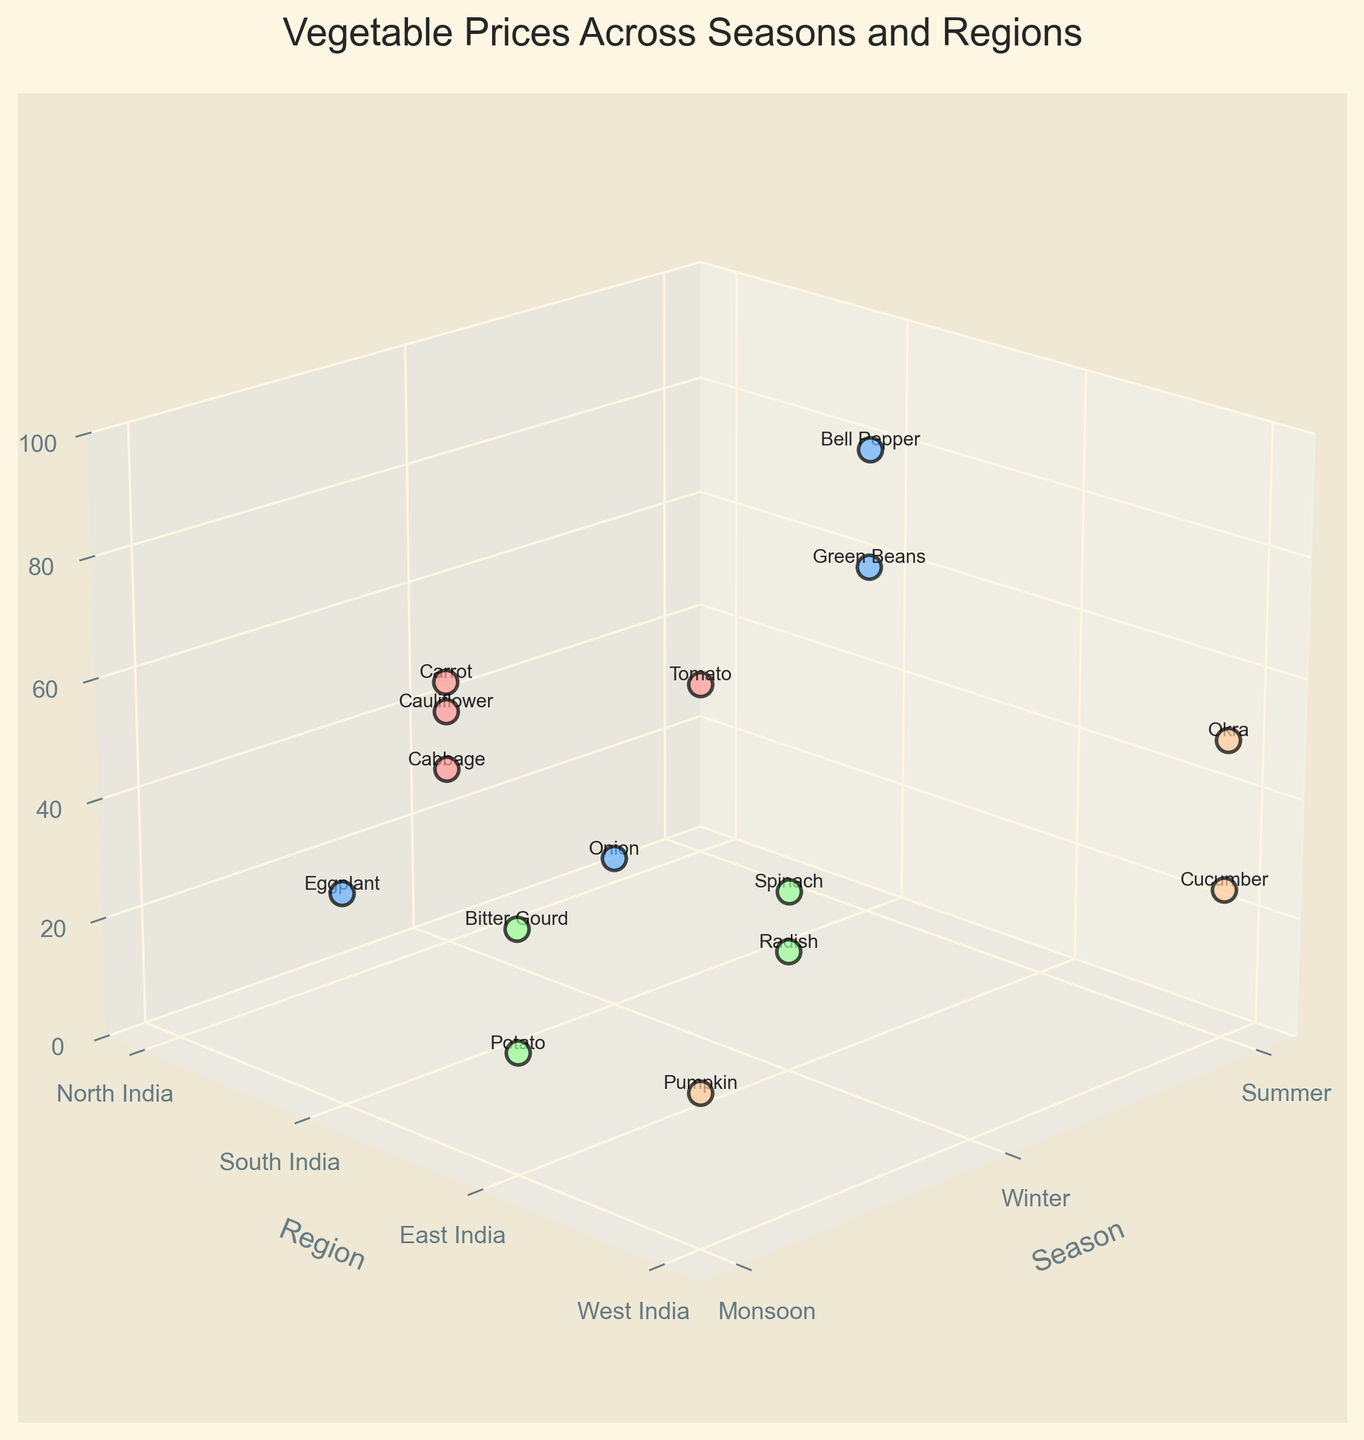What is the title of the figure? The title of the figure is typically located at the top and describes the content of the chart.
Answer: Vegetable Prices Across Seasons and Regions How many different regions are represented in the figure? The y-axis label indicates different regions, and the ticks show how many regions are represented.
Answer: Four Which vegetable has the highest price and how much is it? The z-axis shows the price. The highest point on the z-axis indicates the highest price.
Answer: Bell Pepper, ₹80/kg What is the average price of vegetables in North India during the Winter season? Identify the data points where the season is Winter (x=1) and the region is North India (y=0). Then, calculate the average price of those points.
Answer: (25 + 40 + 30 + 45 + 30) / 5 = 34 During which season does South India have the most expensive vegetable, and what is it? Look at the z-axis for the highest price point in South India (y=1) and identify the season (x-axis).
Answer: Summer, Bell Pepper Compare the price of Okra in West India during Summer to the price of Bitter Gourd in East India during Monsoon. Which one is more expensive? Locate both data points (Okra in Summer in West India and Bitter Gourd in Monsoon in East India) and compare their z-axis values.
Answer: Okra, ₹50/kg is more expensive than Bitter Gourd, ₹40/kg How much does the price of Spinach in East India during Winter differ from the price of Tomato in North India during Summer? Find the prices of the two vegetables and calculate the difference.
Answer: ₹30/kg - ₹30/kg = ₹0 What is the total number of data points in the chart? Count all the scatter points presented in the 3D plot.
Answer: 15 Which vegetable in North India is the cheapest and during which season is it available? Look for the lowest z-axis value among the data points in North India (y=0) and identify the vegetable and its season.
Answer: Radish, Winter What is the median price of vegetables in the Monsoon season? Identify all data points in the Monsoon season (x=2), list their prices, and find the middle value.
Answer: Median of [20, 35, 40, 25] = 30 